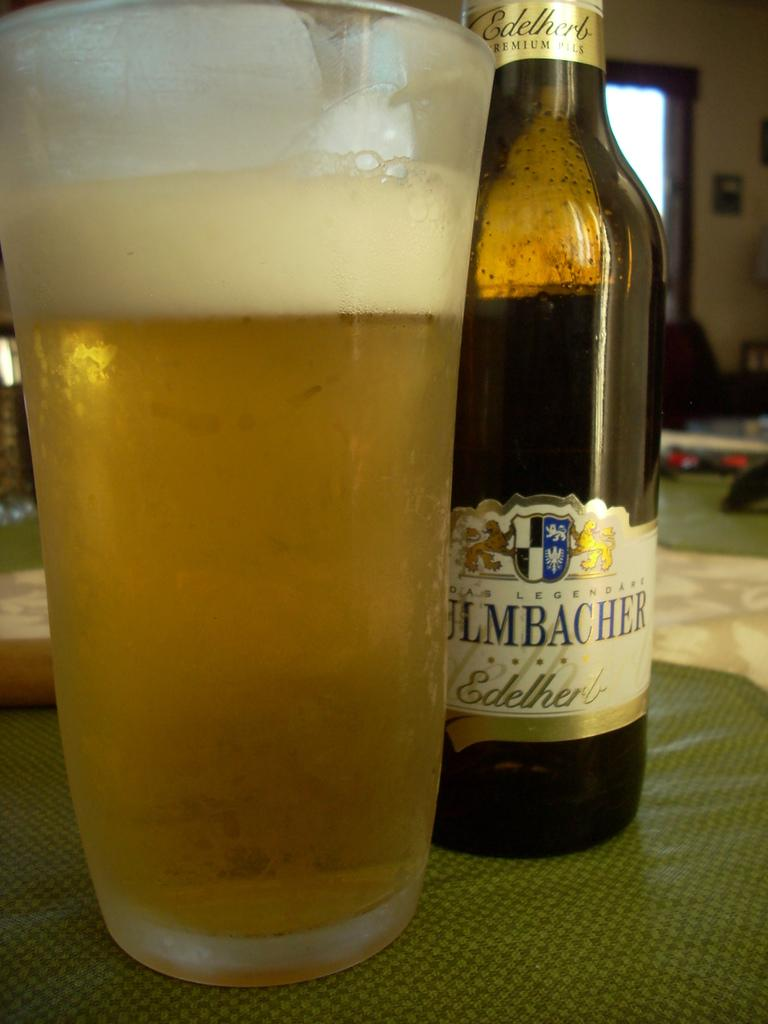<image>
Create a compact narrative representing the image presented. a bottle of edelhert beer standing next to a glass of it 